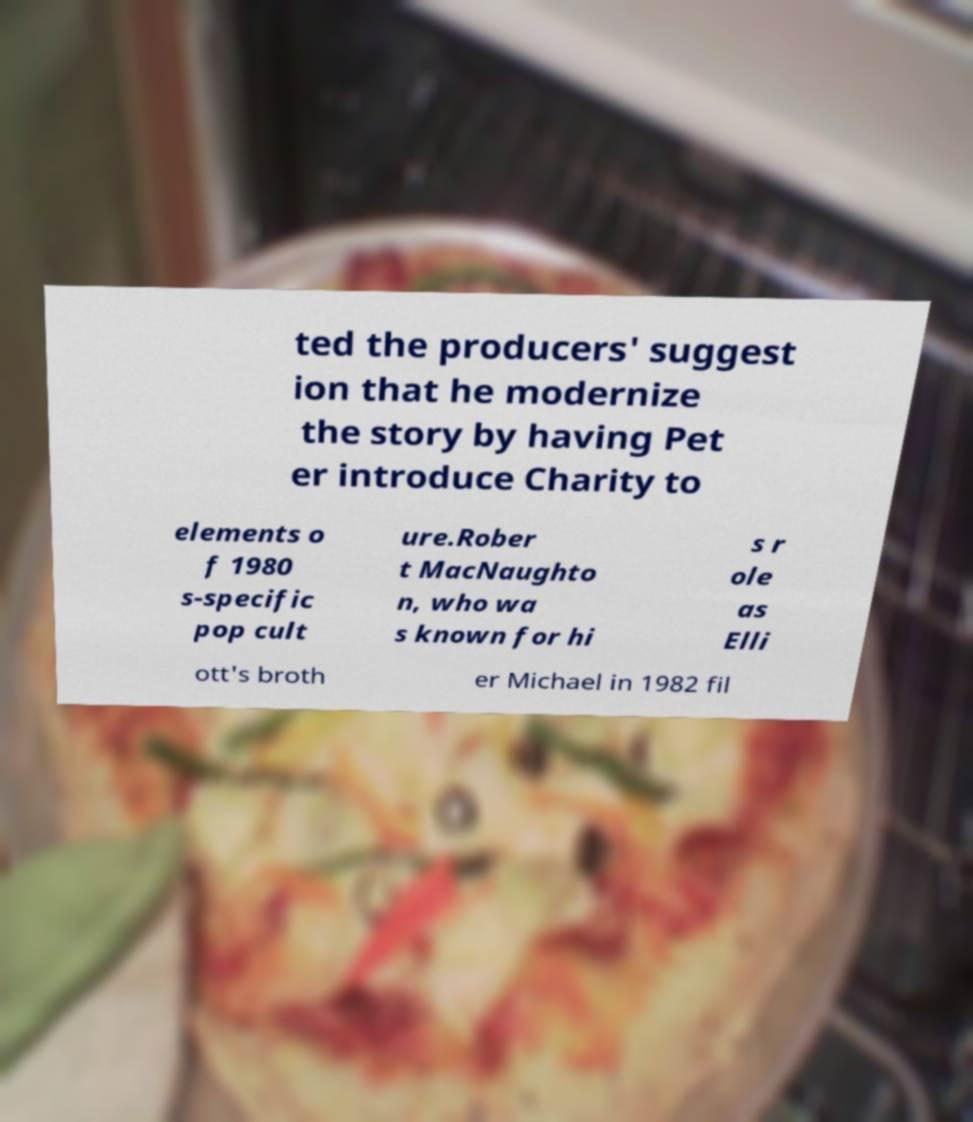For documentation purposes, I need the text within this image transcribed. Could you provide that? ted the producers' suggest ion that he modernize the story by having Pet er introduce Charity to elements o f 1980 s-specific pop cult ure.Rober t MacNaughto n, who wa s known for hi s r ole as Elli ott's broth er Michael in 1982 fil 